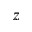<formula> <loc_0><loc_0><loc_500><loc_500>z</formula> 